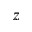<formula> <loc_0><loc_0><loc_500><loc_500>z</formula> 